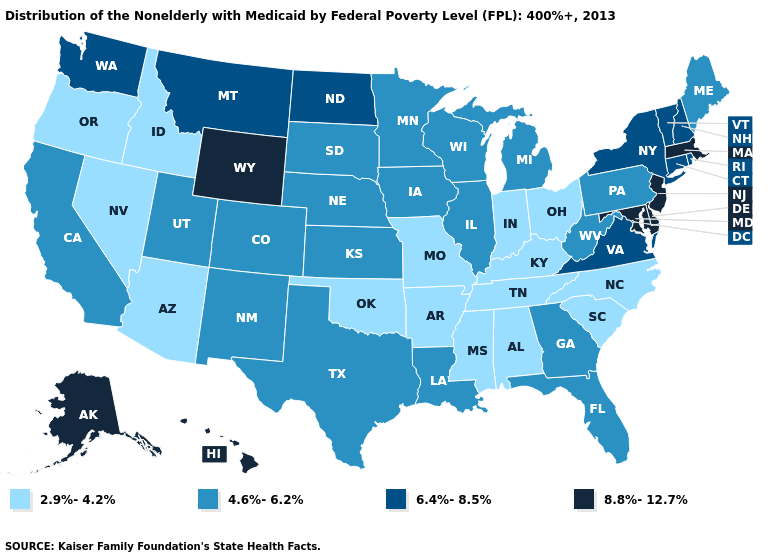Does the map have missing data?
Quick response, please. No. Name the states that have a value in the range 4.6%-6.2%?
Give a very brief answer. California, Colorado, Florida, Georgia, Illinois, Iowa, Kansas, Louisiana, Maine, Michigan, Minnesota, Nebraska, New Mexico, Pennsylvania, South Dakota, Texas, Utah, West Virginia, Wisconsin. What is the value of Maryland?
Give a very brief answer. 8.8%-12.7%. Name the states that have a value in the range 2.9%-4.2%?
Short answer required. Alabama, Arizona, Arkansas, Idaho, Indiana, Kentucky, Mississippi, Missouri, Nevada, North Carolina, Ohio, Oklahoma, Oregon, South Carolina, Tennessee. What is the value of Oregon?
Be succinct. 2.9%-4.2%. Does Pennsylvania have the same value as Alaska?
Be succinct. No. Does the map have missing data?
Keep it brief. No. Does Minnesota have a higher value than Washington?
Answer briefly. No. What is the value of Massachusetts?
Concise answer only. 8.8%-12.7%. Name the states that have a value in the range 8.8%-12.7%?
Be succinct. Alaska, Delaware, Hawaii, Maryland, Massachusetts, New Jersey, Wyoming. Name the states that have a value in the range 4.6%-6.2%?
Give a very brief answer. California, Colorado, Florida, Georgia, Illinois, Iowa, Kansas, Louisiana, Maine, Michigan, Minnesota, Nebraska, New Mexico, Pennsylvania, South Dakota, Texas, Utah, West Virginia, Wisconsin. What is the lowest value in the USA?
Be succinct. 2.9%-4.2%. Name the states that have a value in the range 4.6%-6.2%?
Short answer required. California, Colorado, Florida, Georgia, Illinois, Iowa, Kansas, Louisiana, Maine, Michigan, Minnesota, Nebraska, New Mexico, Pennsylvania, South Dakota, Texas, Utah, West Virginia, Wisconsin. What is the value of Maine?
Concise answer only. 4.6%-6.2%. Does Massachusetts have the highest value in the USA?
Short answer required. Yes. 